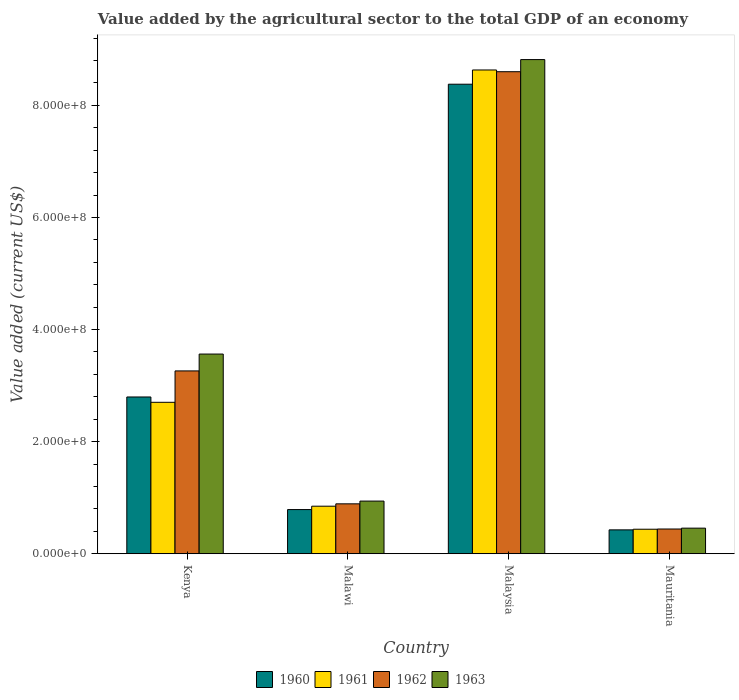How many groups of bars are there?
Ensure brevity in your answer.  4. Are the number of bars per tick equal to the number of legend labels?
Make the answer very short. Yes. How many bars are there on the 4th tick from the left?
Provide a short and direct response. 4. What is the label of the 3rd group of bars from the left?
Your answer should be very brief. Malaysia. What is the value added by the agricultural sector to the total GDP in 1962 in Malawi?
Your answer should be compact. 8.90e+07. Across all countries, what is the maximum value added by the agricultural sector to the total GDP in 1960?
Give a very brief answer. 8.38e+08. Across all countries, what is the minimum value added by the agricultural sector to the total GDP in 1960?
Make the answer very short. 4.26e+07. In which country was the value added by the agricultural sector to the total GDP in 1961 maximum?
Ensure brevity in your answer.  Malaysia. In which country was the value added by the agricultural sector to the total GDP in 1961 minimum?
Provide a short and direct response. Mauritania. What is the total value added by the agricultural sector to the total GDP in 1960 in the graph?
Provide a succinct answer. 1.24e+09. What is the difference between the value added by the agricultural sector to the total GDP in 1960 in Kenya and that in Malawi?
Provide a short and direct response. 2.01e+08. What is the difference between the value added by the agricultural sector to the total GDP in 1962 in Mauritania and the value added by the agricultural sector to the total GDP in 1960 in Malawi?
Your response must be concise. -3.47e+07. What is the average value added by the agricultural sector to the total GDP in 1963 per country?
Offer a terse response. 3.44e+08. What is the difference between the value added by the agricultural sector to the total GDP of/in 1962 and value added by the agricultural sector to the total GDP of/in 1963 in Malaysia?
Your response must be concise. -2.16e+07. What is the ratio of the value added by the agricultural sector to the total GDP in 1962 in Kenya to that in Mauritania?
Your answer should be compact. 7.39. Is the difference between the value added by the agricultural sector to the total GDP in 1962 in Malawi and Mauritania greater than the difference between the value added by the agricultural sector to the total GDP in 1963 in Malawi and Mauritania?
Keep it short and to the point. No. What is the difference between the highest and the second highest value added by the agricultural sector to the total GDP in 1960?
Make the answer very short. -5.58e+08. What is the difference between the highest and the lowest value added by the agricultural sector to the total GDP in 1962?
Give a very brief answer. 8.16e+08. In how many countries, is the value added by the agricultural sector to the total GDP in 1963 greater than the average value added by the agricultural sector to the total GDP in 1963 taken over all countries?
Your answer should be very brief. 2. How many bars are there?
Your answer should be compact. 16. How many countries are there in the graph?
Provide a succinct answer. 4. Are the values on the major ticks of Y-axis written in scientific E-notation?
Keep it short and to the point. Yes. How many legend labels are there?
Offer a very short reply. 4. How are the legend labels stacked?
Ensure brevity in your answer.  Horizontal. What is the title of the graph?
Your answer should be compact. Value added by the agricultural sector to the total GDP of an economy. What is the label or title of the X-axis?
Your response must be concise. Country. What is the label or title of the Y-axis?
Offer a terse response. Value added (current US$). What is the Value added (current US$) of 1960 in Kenya?
Make the answer very short. 2.80e+08. What is the Value added (current US$) of 1961 in Kenya?
Give a very brief answer. 2.70e+08. What is the Value added (current US$) in 1962 in Kenya?
Your response must be concise. 3.26e+08. What is the Value added (current US$) in 1963 in Kenya?
Your answer should be very brief. 3.56e+08. What is the Value added (current US$) in 1960 in Malawi?
Offer a terse response. 7.88e+07. What is the Value added (current US$) in 1961 in Malawi?
Offer a very short reply. 8.48e+07. What is the Value added (current US$) of 1962 in Malawi?
Keep it short and to the point. 8.90e+07. What is the Value added (current US$) in 1963 in Malawi?
Provide a short and direct response. 9.39e+07. What is the Value added (current US$) of 1960 in Malaysia?
Your answer should be compact. 8.38e+08. What is the Value added (current US$) of 1961 in Malaysia?
Your response must be concise. 8.63e+08. What is the Value added (current US$) in 1962 in Malaysia?
Give a very brief answer. 8.60e+08. What is the Value added (current US$) in 1963 in Malaysia?
Your answer should be very brief. 8.82e+08. What is the Value added (current US$) in 1960 in Mauritania?
Ensure brevity in your answer.  4.26e+07. What is the Value added (current US$) of 1961 in Mauritania?
Offer a terse response. 4.37e+07. What is the Value added (current US$) in 1962 in Mauritania?
Provide a short and direct response. 4.41e+07. What is the Value added (current US$) of 1963 in Mauritania?
Your answer should be very brief. 4.57e+07. Across all countries, what is the maximum Value added (current US$) in 1960?
Offer a terse response. 8.38e+08. Across all countries, what is the maximum Value added (current US$) of 1961?
Your answer should be compact. 8.63e+08. Across all countries, what is the maximum Value added (current US$) of 1962?
Ensure brevity in your answer.  8.60e+08. Across all countries, what is the maximum Value added (current US$) of 1963?
Keep it short and to the point. 8.82e+08. Across all countries, what is the minimum Value added (current US$) of 1960?
Offer a very short reply. 4.26e+07. Across all countries, what is the minimum Value added (current US$) of 1961?
Offer a terse response. 4.37e+07. Across all countries, what is the minimum Value added (current US$) of 1962?
Provide a succinct answer. 4.41e+07. Across all countries, what is the minimum Value added (current US$) of 1963?
Offer a very short reply. 4.57e+07. What is the total Value added (current US$) in 1960 in the graph?
Give a very brief answer. 1.24e+09. What is the total Value added (current US$) of 1961 in the graph?
Your response must be concise. 1.26e+09. What is the total Value added (current US$) in 1962 in the graph?
Offer a terse response. 1.32e+09. What is the total Value added (current US$) in 1963 in the graph?
Your answer should be compact. 1.38e+09. What is the difference between the Value added (current US$) in 1960 in Kenya and that in Malawi?
Provide a succinct answer. 2.01e+08. What is the difference between the Value added (current US$) of 1961 in Kenya and that in Malawi?
Provide a short and direct response. 1.85e+08. What is the difference between the Value added (current US$) of 1962 in Kenya and that in Malawi?
Keep it short and to the point. 2.37e+08. What is the difference between the Value added (current US$) of 1963 in Kenya and that in Malawi?
Keep it short and to the point. 2.62e+08. What is the difference between the Value added (current US$) of 1960 in Kenya and that in Malaysia?
Give a very brief answer. -5.58e+08. What is the difference between the Value added (current US$) in 1961 in Kenya and that in Malaysia?
Offer a terse response. -5.93e+08. What is the difference between the Value added (current US$) of 1962 in Kenya and that in Malaysia?
Provide a succinct answer. -5.34e+08. What is the difference between the Value added (current US$) of 1963 in Kenya and that in Malaysia?
Your answer should be compact. -5.25e+08. What is the difference between the Value added (current US$) in 1960 in Kenya and that in Mauritania?
Keep it short and to the point. 2.37e+08. What is the difference between the Value added (current US$) in 1961 in Kenya and that in Mauritania?
Provide a succinct answer. 2.26e+08. What is the difference between the Value added (current US$) of 1962 in Kenya and that in Mauritania?
Your response must be concise. 2.82e+08. What is the difference between the Value added (current US$) of 1963 in Kenya and that in Mauritania?
Your answer should be compact. 3.11e+08. What is the difference between the Value added (current US$) in 1960 in Malawi and that in Malaysia?
Give a very brief answer. -7.59e+08. What is the difference between the Value added (current US$) in 1961 in Malawi and that in Malaysia?
Your response must be concise. -7.78e+08. What is the difference between the Value added (current US$) of 1962 in Malawi and that in Malaysia?
Make the answer very short. -7.71e+08. What is the difference between the Value added (current US$) in 1963 in Malawi and that in Malaysia?
Your answer should be compact. -7.88e+08. What is the difference between the Value added (current US$) of 1960 in Malawi and that in Mauritania?
Offer a very short reply. 3.62e+07. What is the difference between the Value added (current US$) in 1961 in Malawi and that in Mauritania?
Ensure brevity in your answer.  4.11e+07. What is the difference between the Value added (current US$) of 1962 in Malawi and that in Mauritania?
Keep it short and to the point. 4.49e+07. What is the difference between the Value added (current US$) of 1963 in Malawi and that in Mauritania?
Provide a succinct answer. 4.83e+07. What is the difference between the Value added (current US$) in 1960 in Malaysia and that in Mauritania?
Ensure brevity in your answer.  7.95e+08. What is the difference between the Value added (current US$) in 1961 in Malaysia and that in Mauritania?
Provide a succinct answer. 8.19e+08. What is the difference between the Value added (current US$) of 1962 in Malaysia and that in Mauritania?
Ensure brevity in your answer.  8.16e+08. What is the difference between the Value added (current US$) in 1963 in Malaysia and that in Mauritania?
Your answer should be very brief. 8.36e+08. What is the difference between the Value added (current US$) in 1960 in Kenya and the Value added (current US$) in 1961 in Malawi?
Offer a very short reply. 1.95e+08. What is the difference between the Value added (current US$) of 1960 in Kenya and the Value added (current US$) of 1962 in Malawi?
Your answer should be very brief. 1.91e+08. What is the difference between the Value added (current US$) of 1960 in Kenya and the Value added (current US$) of 1963 in Malawi?
Give a very brief answer. 1.86e+08. What is the difference between the Value added (current US$) in 1961 in Kenya and the Value added (current US$) in 1962 in Malawi?
Offer a very short reply. 1.81e+08. What is the difference between the Value added (current US$) of 1961 in Kenya and the Value added (current US$) of 1963 in Malawi?
Ensure brevity in your answer.  1.76e+08. What is the difference between the Value added (current US$) of 1962 in Kenya and the Value added (current US$) of 1963 in Malawi?
Keep it short and to the point. 2.32e+08. What is the difference between the Value added (current US$) in 1960 in Kenya and the Value added (current US$) in 1961 in Malaysia?
Your response must be concise. -5.83e+08. What is the difference between the Value added (current US$) in 1960 in Kenya and the Value added (current US$) in 1962 in Malaysia?
Make the answer very short. -5.80e+08. What is the difference between the Value added (current US$) of 1960 in Kenya and the Value added (current US$) of 1963 in Malaysia?
Provide a succinct answer. -6.02e+08. What is the difference between the Value added (current US$) of 1961 in Kenya and the Value added (current US$) of 1962 in Malaysia?
Ensure brevity in your answer.  -5.90e+08. What is the difference between the Value added (current US$) in 1961 in Kenya and the Value added (current US$) in 1963 in Malaysia?
Your response must be concise. -6.11e+08. What is the difference between the Value added (current US$) in 1962 in Kenya and the Value added (current US$) in 1963 in Malaysia?
Give a very brief answer. -5.55e+08. What is the difference between the Value added (current US$) of 1960 in Kenya and the Value added (current US$) of 1961 in Mauritania?
Your answer should be compact. 2.36e+08. What is the difference between the Value added (current US$) of 1960 in Kenya and the Value added (current US$) of 1962 in Mauritania?
Provide a succinct answer. 2.36e+08. What is the difference between the Value added (current US$) in 1960 in Kenya and the Value added (current US$) in 1963 in Mauritania?
Your answer should be compact. 2.34e+08. What is the difference between the Value added (current US$) in 1961 in Kenya and the Value added (current US$) in 1962 in Mauritania?
Your answer should be compact. 2.26e+08. What is the difference between the Value added (current US$) in 1961 in Kenya and the Value added (current US$) in 1963 in Mauritania?
Your answer should be compact. 2.25e+08. What is the difference between the Value added (current US$) in 1962 in Kenya and the Value added (current US$) in 1963 in Mauritania?
Your response must be concise. 2.81e+08. What is the difference between the Value added (current US$) in 1960 in Malawi and the Value added (current US$) in 1961 in Malaysia?
Your response must be concise. -7.84e+08. What is the difference between the Value added (current US$) of 1960 in Malawi and the Value added (current US$) of 1962 in Malaysia?
Make the answer very short. -7.81e+08. What is the difference between the Value added (current US$) in 1960 in Malawi and the Value added (current US$) in 1963 in Malaysia?
Your answer should be very brief. -8.03e+08. What is the difference between the Value added (current US$) of 1961 in Malawi and the Value added (current US$) of 1962 in Malaysia?
Make the answer very short. -7.75e+08. What is the difference between the Value added (current US$) of 1961 in Malawi and the Value added (current US$) of 1963 in Malaysia?
Make the answer very short. -7.97e+08. What is the difference between the Value added (current US$) of 1962 in Malawi and the Value added (current US$) of 1963 in Malaysia?
Provide a short and direct response. -7.93e+08. What is the difference between the Value added (current US$) of 1960 in Malawi and the Value added (current US$) of 1961 in Mauritania?
Provide a succinct answer. 3.51e+07. What is the difference between the Value added (current US$) in 1960 in Malawi and the Value added (current US$) in 1962 in Mauritania?
Keep it short and to the point. 3.47e+07. What is the difference between the Value added (current US$) of 1960 in Malawi and the Value added (current US$) of 1963 in Mauritania?
Your answer should be very brief. 3.32e+07. What is the difference between the Value added (current US$) of 1961 in Malawi and the Value added (current US$) of 1962 in Mauritania?
Offer a terse response. 4.07e+07. What is the difference between the Value added (current US$) of 1961 in Malawi and the Value added (current US$) of 1963 in Mauritania?
Provide a short and direct response. 3.92e+07. What is the difference between the Value added (current US$) in 1962 in Malawi and the Value added (current US$) in 1963 in Mauritania?
Offer a terse response. 4.34e+07. What is the difference between the Value added (current US$) of 1960 in Malaysia and the Value added (current US$) of 1961 in Mauritania?
Provide a succinct answer. 7.94e+08. What is the difference between the Value added (current US$) in 1960 in Malaysia and the Value added (current US$) in 1962 in Mauritania?
Provide a succinct answer. 7.94e+08. What is the difference between the Value added (current US$) of 1960 in Malaysia and the Value added (current US$) of 1963 in Mauritania?
Offer a terse response. 7.92e+08. What is the difference between the Value added (current US$) of 1961 in Malaysia and the Value added (current US$) of 1962 in Mauritania?
Ensure brevity in your answer.  8.19e+08. What is the difference between the Value added (current US$) of 1961 in Malaysia and the Value added (current US$) of 1963 in Mauritania?
Keep it short and to the point. 8.17e+08. What is the difference between the Value added (current US$) in 1962 in Malaysia and the Value added (current US$) in 1963 in Mauritania?
Offer a terse response. 8.14e+08. What is the average Value added (current US$) of 1960 per country?
Give a very brief answer. 3.10e+08. What is the average Value added (current US$) in 1961 per country?
Offer a terse response. 3.15e+08. What is the average Value added (current US$) of 1962 per country?
Offer a very short reply. 3.30e+08. What is the average Value added (current US$) in 1963 per country?
Provide a succinct answer. 3.44e+08. What is the difference between the Value added (current US$) of 1960 and Value added (current US$) of 1961 in Kenya?
Give a very brief answer. 9.51e+06. What is the difference between the Value added (current US$) of 1960 and Value added (current US$) of 1962 in Kenya?
Ensure brevity in your answer.  -4.65e+07. What is the difference between the Value added (current US$) of 1960 and Value added (current US$) of 1963 in Kenya?
Provide a succinct answer. -7.66e+07. What is the difference between the Value added (current US$) in 1961 and Value added (current US$) in 1962 in Kenya?
Give a very brief answer. -5.60e+07. What is the difference between the Value added (current US$) of 1961 and Value added (current US$) of 1963 in Kenya?
Your response must be concise. -8.61e+07. What is the difference between the Value added (current US$) in 1962 and Value added (current US$) in 1963 in Kenya?
Your answer should be compact. -3.01e+07. What is the difference between the Value added (current US$) of 1960 and Value added (current US$) of 1961 in Malawi?
Your answer should be very brief. -6.02e+06. What is the difference between the Value added (current US$) of 1960 and Value added (current US$) of 1962 in Malawi?
Your answer should be compact. -1.02e+07. What is the difference between the Value added (current US$) in 1960 and Value added (current US$) in 1963 in Malawi?
Ensure brevity in your answer.  -1.51e+07. What is the difference between the Value added (current US$) in 1961 and Value added (current US$) in 1962 in Malawi?
Make the answer very short. -4.20e+06. What is the difference between the Value added (current US$) of 1961 and Value added (current US$) of 1963 in Malawi?
Keep it short and to the point. -9.10e+06. What is the difference between the Value added (current US$) in 1962 and Value added (current US$) in 1963 in Malawi?
Provide a succinct answer. -4.90e+06. What is the difference between the Value added (current US$) in 1960 and Value added (current US$) in 1961 in Malaysia?
Offer a terse response. -2.54e+07. What is the difference between the Value added (current US$) of 1960 and Value added (current US$) of 1962 in Malaysia?
Offer a terse response. -2.23e+07. What is the difference between the Value added (current US$) of 1960 and Value added (current US$) of 1963 in Malaysia?
Ensure brevity in your answer.  -4.39e+07. What is the difference between the Value added (current US$) in 1961 and Value added (current US$) in 1962 in Malaysia?
Your answer should be compact. 3.09e+06. What is the difference between the Value added (current US$) in 1961 and Value added (current US$) in 1963 in Malaysia?
Your response must be concise. -1.85e+07. What is the difference between the Value added (current US$) in 1962 and Value added (current US$) in 1963 in Malaysia?
Offer a terse response. -2.16e+07. What is the difference between the Value added (current US$) in 1960 and Value added (current US$) in 1961 in Mauritania?
Offer a terse response. -1.15e+06. What is the difference between the Value added (current US$) of 1960 and Value added (current US$) of 1962 in Mauritania?
Your answer should be compact. -1.54e+06. What is the difference between the Value added (current US$) of 1960 and Value added (current US$) of 1963 in Mauritania?
Provide a succinct answer. -3.07e+06. What is the difference between the Value added (current US$) of 1961 and Value added (current US$) of 1962 in Mauritania?
Give a very brief answer. -3.84e+05. What is the difference between the Value added (current US$) in 1961 and Value added (current US$) in 1963 in Mauritania?
Your response must be concise. -1.92e+06. What is the difference between the Value added (current US$) in 1962 and Value added (current US$) in 1963 in Mauritania?
Offer a terse response. -1.54e+06. What is the ratio of the Value added (current US$) in 1960 in Kenya to that in Malawi?
Your answer should be compact. 3.55. What is the ratio of the Value added (current US$) in 1961 in Kenya to that in Malawi?
Keep it short and to the point. 3.18. What is the ratio of the Value added (current US$) of 1962 in Kenya to that in Malawi?
Keep it short and to the point. 3.66. What is the ratio of the Value added (current US$) in 1963 in Kenya to that in Malawi?
Give a very brief answer. 3.79. What is the ratio of the Value added (current US$) of 1960 in Kenya to that in Malaysia?
Ensure brevity in your answer.  0.33. What is the ratio of the Value added (current US$) of 1961 in Kenya to that in Malaysia?
Offer a very short reply. 0.31. What is the ratio of the Value added (current US$) in 1962 in Kenya to that in Malaysia?
Provide a short and direct response. 0.38. What is the ratio of the Value added (current US$) in 1963 in Kenya to that in Malaysia?
Ensure brevity in your answer.  0.4. What is the ratio of the Value added (current US$) of 1960 in Kenya to that in Mauritania?
Keep it short and to the point. 6.57. What is the ratio of the Value added (current US$) in 1961 in Kenya to that in Mauritania?
Give a very brief answer. 6.18. What is the ratio of the Value added (current US$) of 1962 in Kenya to that in Mauritania?
Make the answer very short. 7.39. What is the ratio of the Value added (current US$) of 1963 in Kenya to that in Mauritania?
Keep it short and to the point. 7.8. What is the ratio of the Value added (current US$) of 1960 in Malawi to that in Malaysia?
Your response must be concise. 0.09. What is the ratio of the Value added (current US$) in 1961 in Malawi to that in Malaysia?
Provide a short and direct response. 0.1. What is the ratio of the Value added (current US$) in 1962 in Malawi to that in Malaysia?
Offer a very short reply. 0.1. What is the ratio of the Value added (current US$) of 1963 in Malawi to that in Malaysia?
Keep it short and to the point. 0.11. What is the ratio of the Value added (current US$) of 1960 in Malawi to that in Mauritania?
Provide a short and direct response. 1.85. What is the ratio of the Value added (current US$) in 1961 in Malawi to that in Mauritania?
Your answer should be very brief. 1.94. What is the ratio of the Value added (current US$) in 1962 in Malawi to that in Mauritania?
Provide a short and direct response. 2.02. What is the ratio of the Value added (current US$) of 1963 in Malawi to that in Mauritania?
Your answer should be compact. 2.06. What is the ratio of the Value added (current US$) of 1960 in Malaysia to that in Mauritania?
Ensure brevity in your answer.  19.67. What is the ratio of the Value added (current US$) of 1961 in Malaysia to that in Mauritania?
Provide a succinct answer. 19.73. What is the ratio of the Value added (current US$) in 1962 in Malaysia to that in Mauritania?
Your answer should be very brief. 19.49. What is the ratio of the Value added (current US$) in 1963 in Malaysia to that in Mauritania?
Keep it short and to the point. 19.31. What is the difference between the highest and the second highest Value added (current US$) in 1960?
Your response must be concise. 5.58e+08. What is the difference between the highest and the second highest Value added (current US$) in 1961?
Your response must be concise. 5.93e+08. What is the difference between the highest and the second highest Value added (current US$) in 1962?
Give a very brief answer. 5.34e+08. What is the difference between the highest and the second highest Value added (current US$) in 1963?
Provide a succinct answer. 5.25e+08. What is the difference between the highest and the lowest Value added (current US$) in 1960?
Provide a short and direct response. 7.95e+08. What is the difference between the highest and the lowest Value added (current US$) in 1961?
Your response must be concise. 8.19e+08. What is the difference between the highest and the lowest Value added (current US$) of 1962?
Ensure brevity in your answer.  8.16e+08. What is the difference between the highest and the lowest Value added (current US$) in 1963?
Your response must be concise. 8.36e+08. 